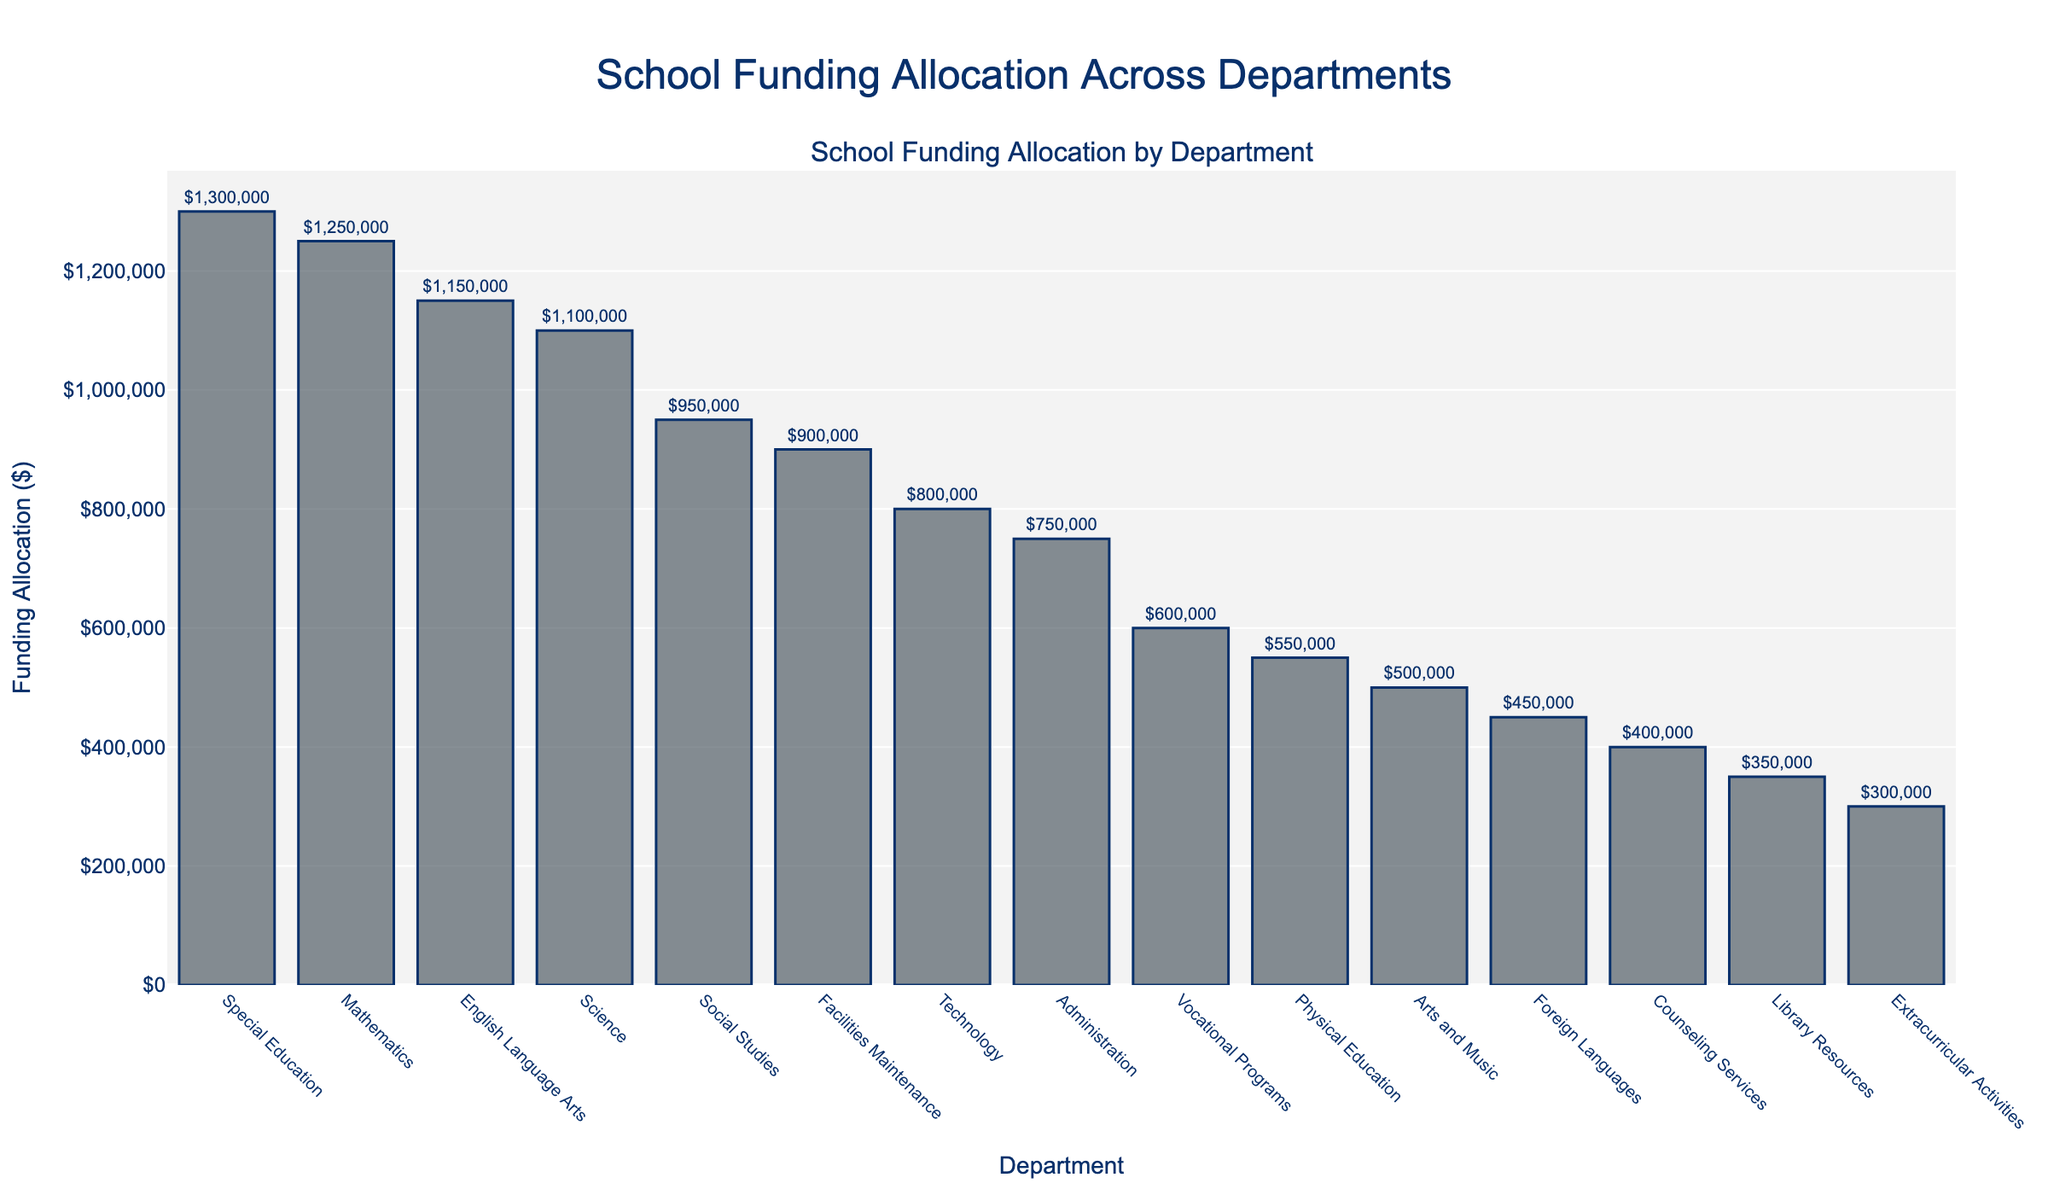Which department has received the highest funding allocation? The figure shows that the Special Education department has the tallest bar, indicating it has received the most funding.
Answer: Special Education Which department received the smallest funding allocation? The shortest bar in the figure corresponds to the Extracurricular Activities department, showing it has the lowest funding.
Answer: Extracurricular Activities How much more funding does the Science department have compared to the Arts and Music department? The Science department received $1,100,000, and the Arts and Music department received $500,000. Subtracting the two gives the difference: $1,100,000 - $500,000 = $600,000.
Answer: $600,000 Which departments have funding allocations over one million dollars? The figure shows that the Special Education, Mathematics, and English Language Arts departments have bars extending over the $1,000,000 mark.
Answer: Special Education, Mathematics, English Language Arts What is the total funding allocation for the Counseling Services and Library Resources departments combined? Counseling Services has $400,000 and Library Resources has $350,000. Adding them together: $400,000 + $350,000 = $750,000.
Answer: $750,000 Between Technology and Administration, which department has more funding, and by how much? Technology has $800,000 and Administration has $750,000. Subtracting the two: $800,000 - $750,000 = $50,000.
Answer: Technology by $50,000 Which department is in the middle (median) in terms of funding allocation? Sorting the departments by funding, the one in the 8th position will be the median. The sorted order is: Special Education, Mathematics, English Language Arts, Science, Social Studies, Facilities Maintenance, Technology, Administration, Vocational Programs, Physical Education, Arts and Music, Foreign Languages, Counseling Services, Library Resources, Extracurricular Activities. The 8th department is Administration.
Answer: Administration How much less funding does the Foreign Languages department have compared to Physical Education? The Foreign Languages department has $450,000 and Physical Education has $550,000. Subtracting the two: $550,000 - $450,000 = $100,000.
Answer: $100,000 What is the total funding allocation across all departments? Adding all the funding allocations together: $1,250,000 + $1,150,000 + $1,100,000 + $950,000 + $550,000 + $500,000 + $450,000 + $1,300,000 + $800,000 + $600,000 + $400,000 + $350,000 + $300,000 + $750,000 + $900,000 = $11,350,000.
Answer: $11,350,000 